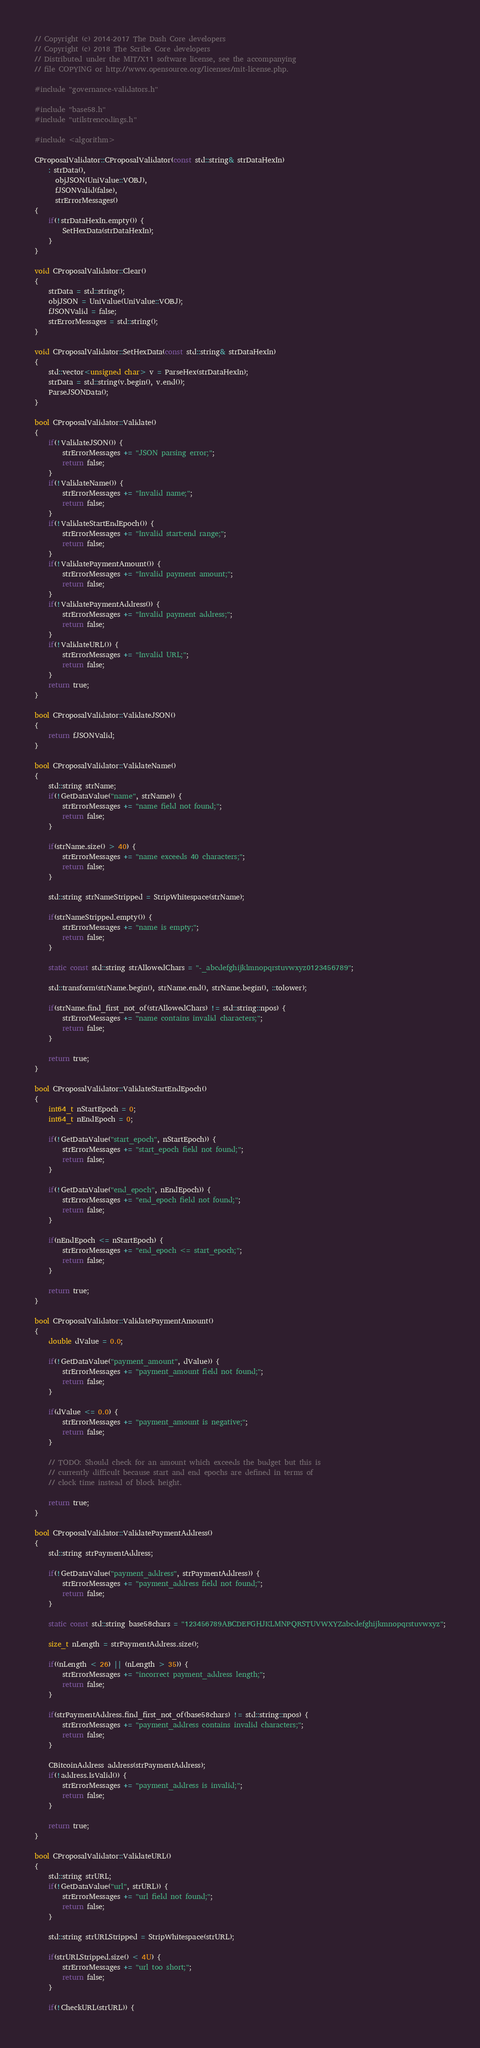<code> <loc_0><loc_0><loc_500><loc_500><_C++_>// Copyright (c) 2014-2017 The Dash Core developers
// Copyright (c) 2018 The Scribe Core developers
// Distributed under the MIT/X11 software license, see the accompanying
// file COPYING or http://www.opensource.org/licenses/mit-license.php.

#include "governance-validators.h"

#include "base58.h"
#include "utilstrencodings.h"

#include <algorithm>

CProposalValidator::CProposalValidator(const std::string& strDataHexIn)
    : strData(),
      objJSON(UniValue::VOBJ),
      fJSONValid(false),
      strErrorMessages()
{
    if(!strDataHexIn.empty()) {
        SetHexData(strDataHexIn);
    }
}

void CProposalValidator::Clear()
{
    strData = std::string();
    objJSON = UniValue(UniValue::VOBJ);
    fJSONValid = false;
    strErrorMessages = std::string();
}

void CProposalValidator::SetHexData(const std::string& strDataHexIn)
{
    std::vector<unsigned char> v = ParseHex(strDataHexIn);
    strData = std::string(v.begin(), v.end());
    ParseJSONData();
}

bool CProposalValidator::Validate()
{
    if(!ValidateJSON()) {
        strErrorMessages += "JSON parsing error;";
        return false;
    }
    if(!ValidateName()) {
        strErrorMessages += "Invalid name;";
        return false;
    }
    if(!ValidateStartEndEpoch()) {
        strErrorMessages += "Invalid start:end range;";
        return false;
    }
    if(!ValidatePaymentAmount()) {
        strErrorMessages += "Invalid payment amount;";
        return false;
    }
    if(!ValidatePaymentAddress()) {
        strErrorMessages += "Invalid payment address;";
        return false;
    }
    if(!ValidateURL()) {
        strErrorMessages += "Invalid URL;";
        return false;
    }
    return true;
}

bool CProposalValidator::ValidateJSON()
{
    return fJSONValid;
}

bool CProposalValidator::ValidateName()
{
    std::string strName;
    if(!GetDataValue("name", strName)) {
        strErrorMessages += "name field not found;";
        return false;
    }

    if(strName.size() > 40) {
        strErrorMessages += "name exceeds 40 characters;";
        return false;
    }

    std::string strNameStripped = StripWhitespace(strName);

    if(strNameStripped.empty()) {
        strErrorMessages += "name is empty;";
        return false;
    }

    static const std::string strAllowedChars = "-_abcdefghijklmnopqrstuvwxyz0123456789";

    std::transform(strName.begin(), strName.end(), strName.begin(), ::tolower);

    if(strName.find_first_not_of(strAllowedChars) != std::string::npos) {
        strErrorMessages += "name contains invalid characters;";
        return false;
    }

    return true;
}

bool CProposalValidator::ValidateStartEndEpoch()
{
    int64_t nStartEpoch = 0;
    int64_t nEndEpoch = 0;

    if(!GetDataValue("start_epoch", nStartEpoch)) {
        strErrorMessages += "start_epoch field not found;";
        return false;
    }

    if(!GetDataValue("end_epoch", nEndEpoch)) {
        strErrorMessages += "end_epoch field not found;";
        return false;
    }

    if(nEndEpoch <= nStartEpoch) {
        strErrorMessages += "end_epoch <= start_epoch;";
        return false;
    }

    return true;
}

bool CProposalValidator::ValidatePaymentAmount()
{
    double dValue = 0.0;

    if(!GetDataValue("payment_amount", dValue)) {
        strErrorMessages += "payment_amount field not found;";
        return false;
    }

    if(dValue <= 0.0) {
        strErrorMessages += "payment_amount is negative;";
        return false;
    }

    // TODO: Should check for an amount which exceeds the budget but this is
    // currently difficult because start and end epochs are defined in terms of
    // clock time instead of block height.

    return true;
}

bool CProposalValidator::ValidatePaymentAddress()
{
    std::string strPaymentAddress;

    if(!GetDataValue("payment_address", strPaymentAddress)) {
        strErrorMessages += "payment_address field not found;";
        return false;
    }

    static const std::string base58chars = "123456789ABCDEFGHJKLMNPQRSTUVWXYZabcdefghijkmnopqrstuvwxyz";

    size_t nLength = strPaymentAddress.size();

    if((nLength < 26) || (nLength > 35)) {
        strErrorMessages += "incorrect payment_address length;";
        return false;
    }

    if(strPaymentAddress.find_first_not_of(base58chars) != std::string::npos) {
        strErrorMessages += "payment_address contains invalid characters;";
        return false;
    }

    CBitcoinAddress address(strPaymentAddress);
    if(!address.IsValid()) {
        strErrorMessages += "payment_address is invalid;";
        return false;
    }

    return true;
}

bool CProposalValidator::ValidateURL()
{
    std::string strURL;
    if(!GetDataValue("url", strURL)) {
        strErrorMessages += "url field not found;";
        return false;
    }

    std::string strURLStripped = StripWhitespace(strURL);

    if(strURLStripped.size() < 4U) {
        strErrorMessages += "url too short;";
        return false;
    }

    if(!CheckURL(strURL)) {</code> 